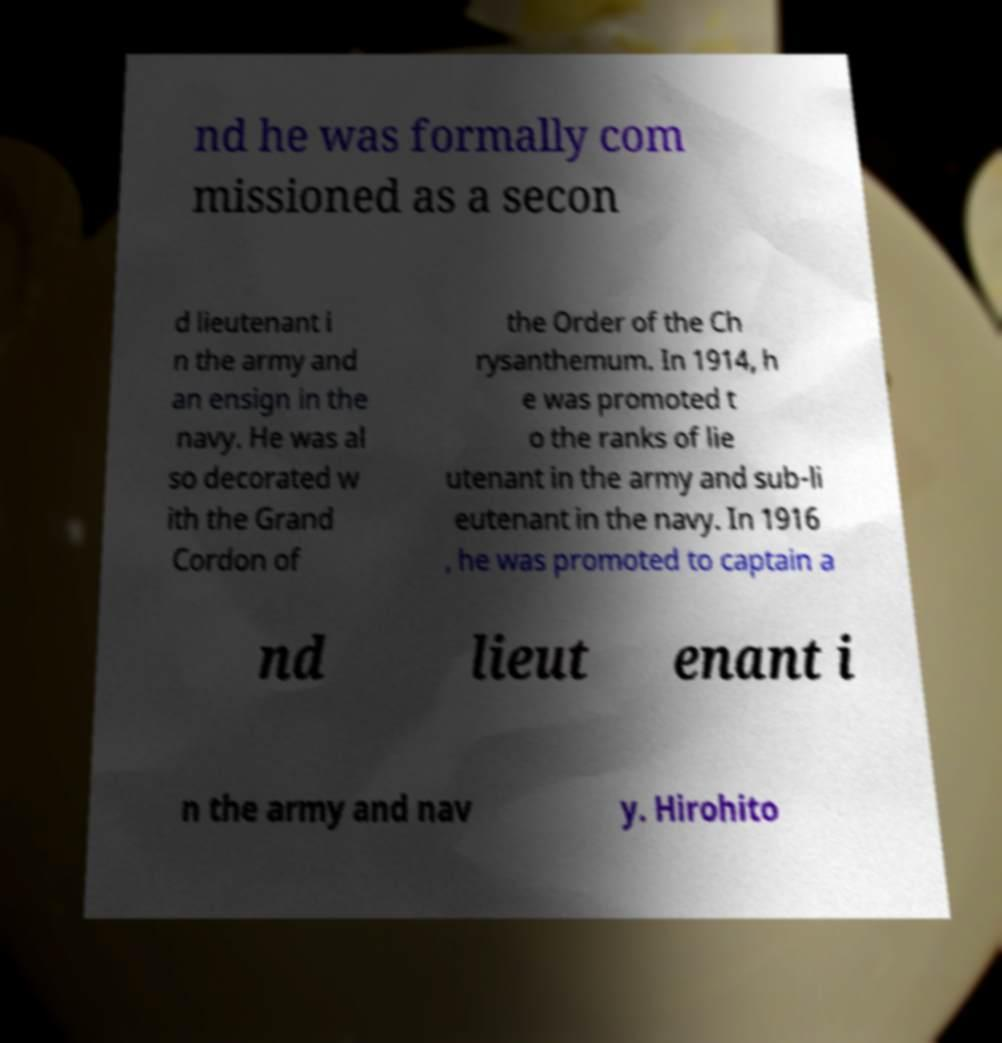Please read and relay the text visible in this image. What does it say? nd he was formally com missioned as a secon d lieutenant i n the army and an ensign in the navy. He was al so decorated w ith the Grand Cordon of the Order of the Ch rysanthemum. In 1914, h e was promoted t o the ranks of lie utenant in the army and sub-li eutenant in the navy. In 1916 , he was promoted to captain a nd lieut enant i n the army and nav y. Hirohito 